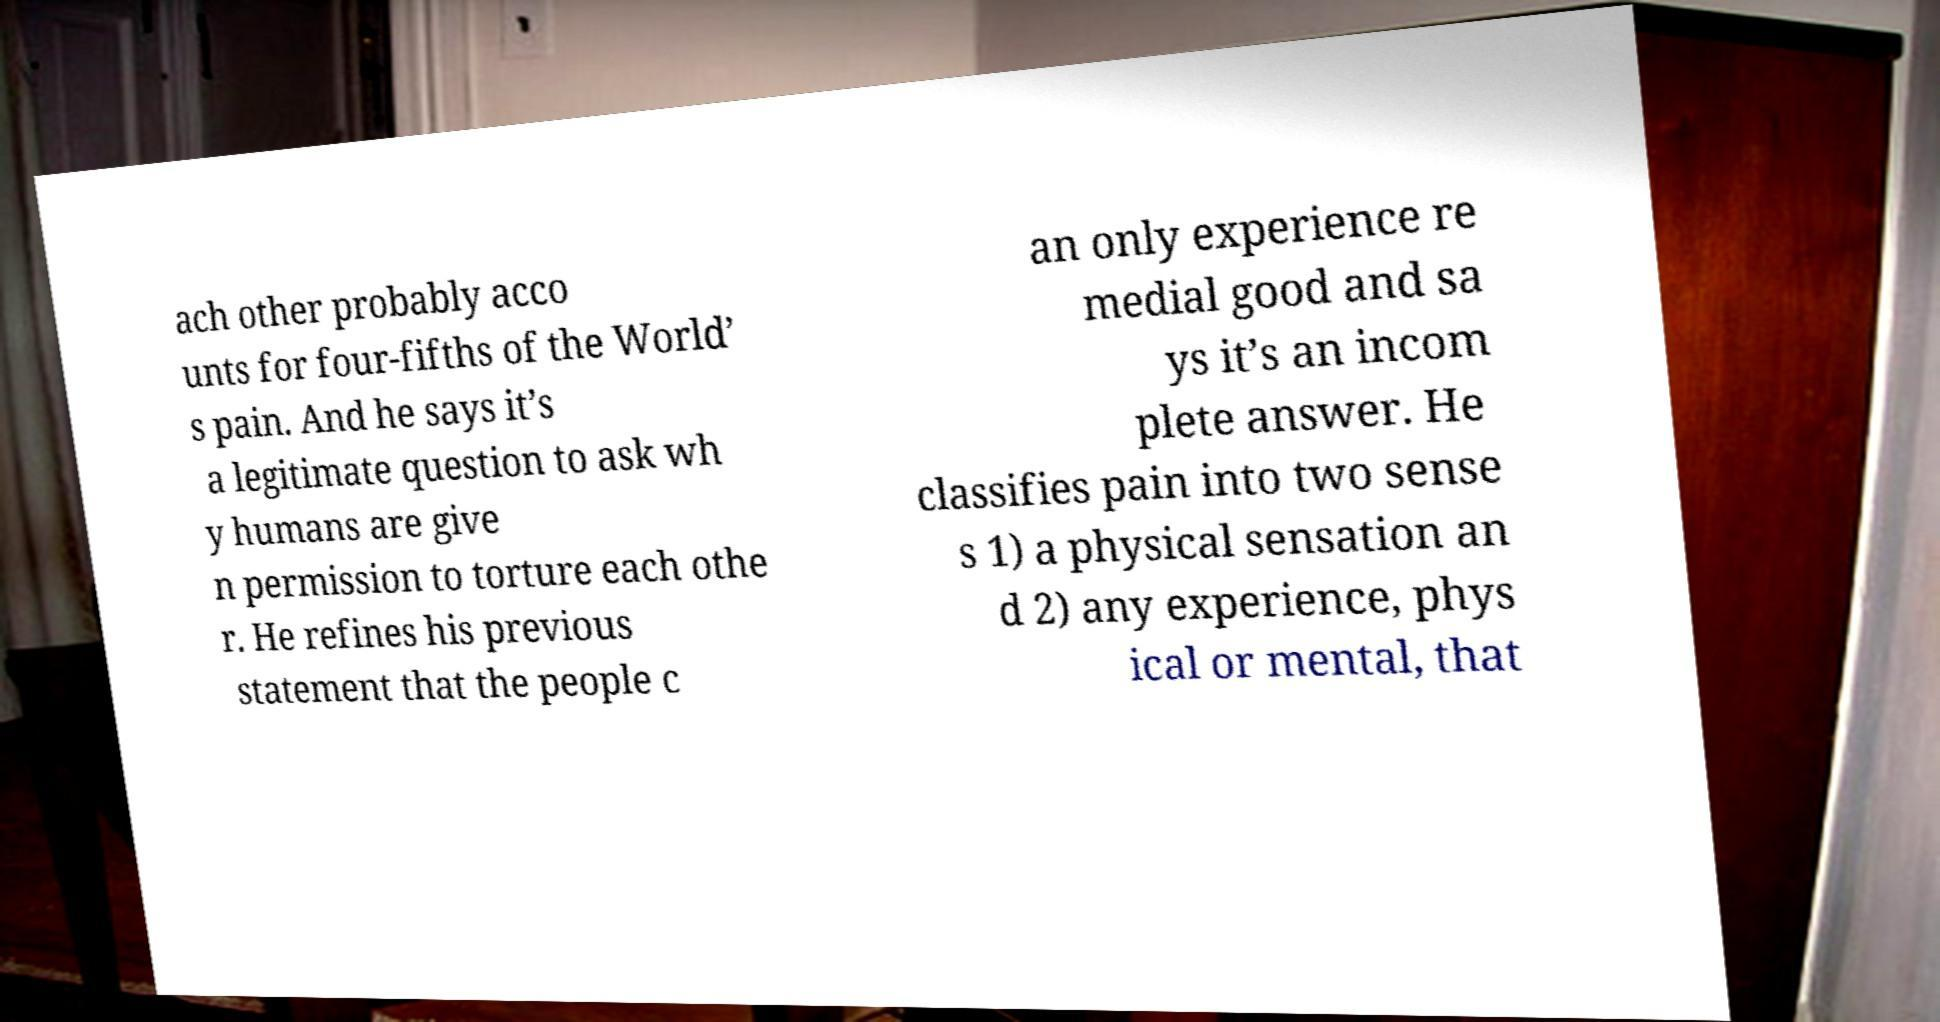Could you assist in decoding the text presented in this image and type it out clearly? ach other probably acco unts for four-fifths of the World’ s pain. And he says it’s a legitimate question to ask wh y humans are give n permission to torture each othe r. He refines his previous statement that the people c an only experience re medial good and sa ys it’s an incom plete answer. He classifies pain into two sense s 1) a physical sensation an d 2) any experience, phys ical or mental, that 